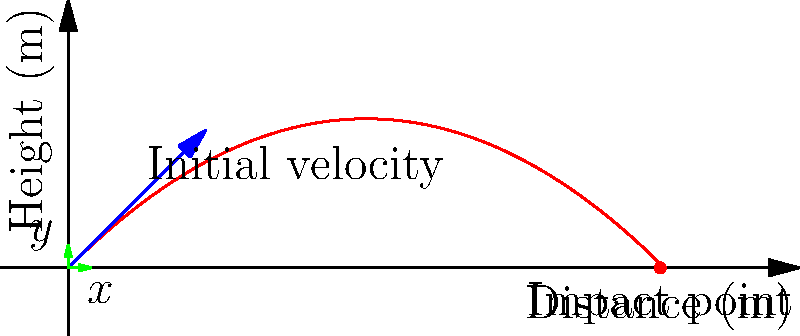In an ancient Slavic fortress, a catapult launches a stone projectile with an initial velocity of 30 m/s at an angle of 45° to the horizontal. Assuming no air resistance, at what distance from the launch point does the stone hit the ground? Round your answer to the nearest meter. To solve this problem, we'll use the equations of motion for projectile motion:

1) For horizontal motion: $x = v_0 \cos(\theta) \cdot t$
2) For vertical motion: $y = v_0 \sin(\theta) \cdot t - \frac{1}{2}gt^2$

Where:
$v_0 = 30$ m/s (initial velocity)
$\theta = 45°$ (launch angle)
$g = 9.8$ m/s² (acceleration due to gravity)

We need to find the time when the stone hits the ground (y = 0):

$0 = v_0 \sin(\theta) \cdot t - \frac{1}{2}gt^2$

Substituting the values:

$0 = 30 \sin(45°) \cdot t - \frac{1}{2} \cdot 9.8 \cdot t^2$

$0 = 21.21 t - 4.9 t^2$

Solving this quadratic equation:

$t = \frac{21.21 \pm \sqrt{21.21^2 + 4 \cdot 4.9 \cdot 0}}{2 \cdot 4.9} \approx 4.33$ s

Now we can use this time in the horizontal motion equation:

$x = v_0 \cos(\theta) \cdot t$
$x = 30 \cos(45°) \cdot 4.33$
$x \approx 91.8$ m

Rounding to the nearest meter, we get 92 m.
Answer: 92 m 